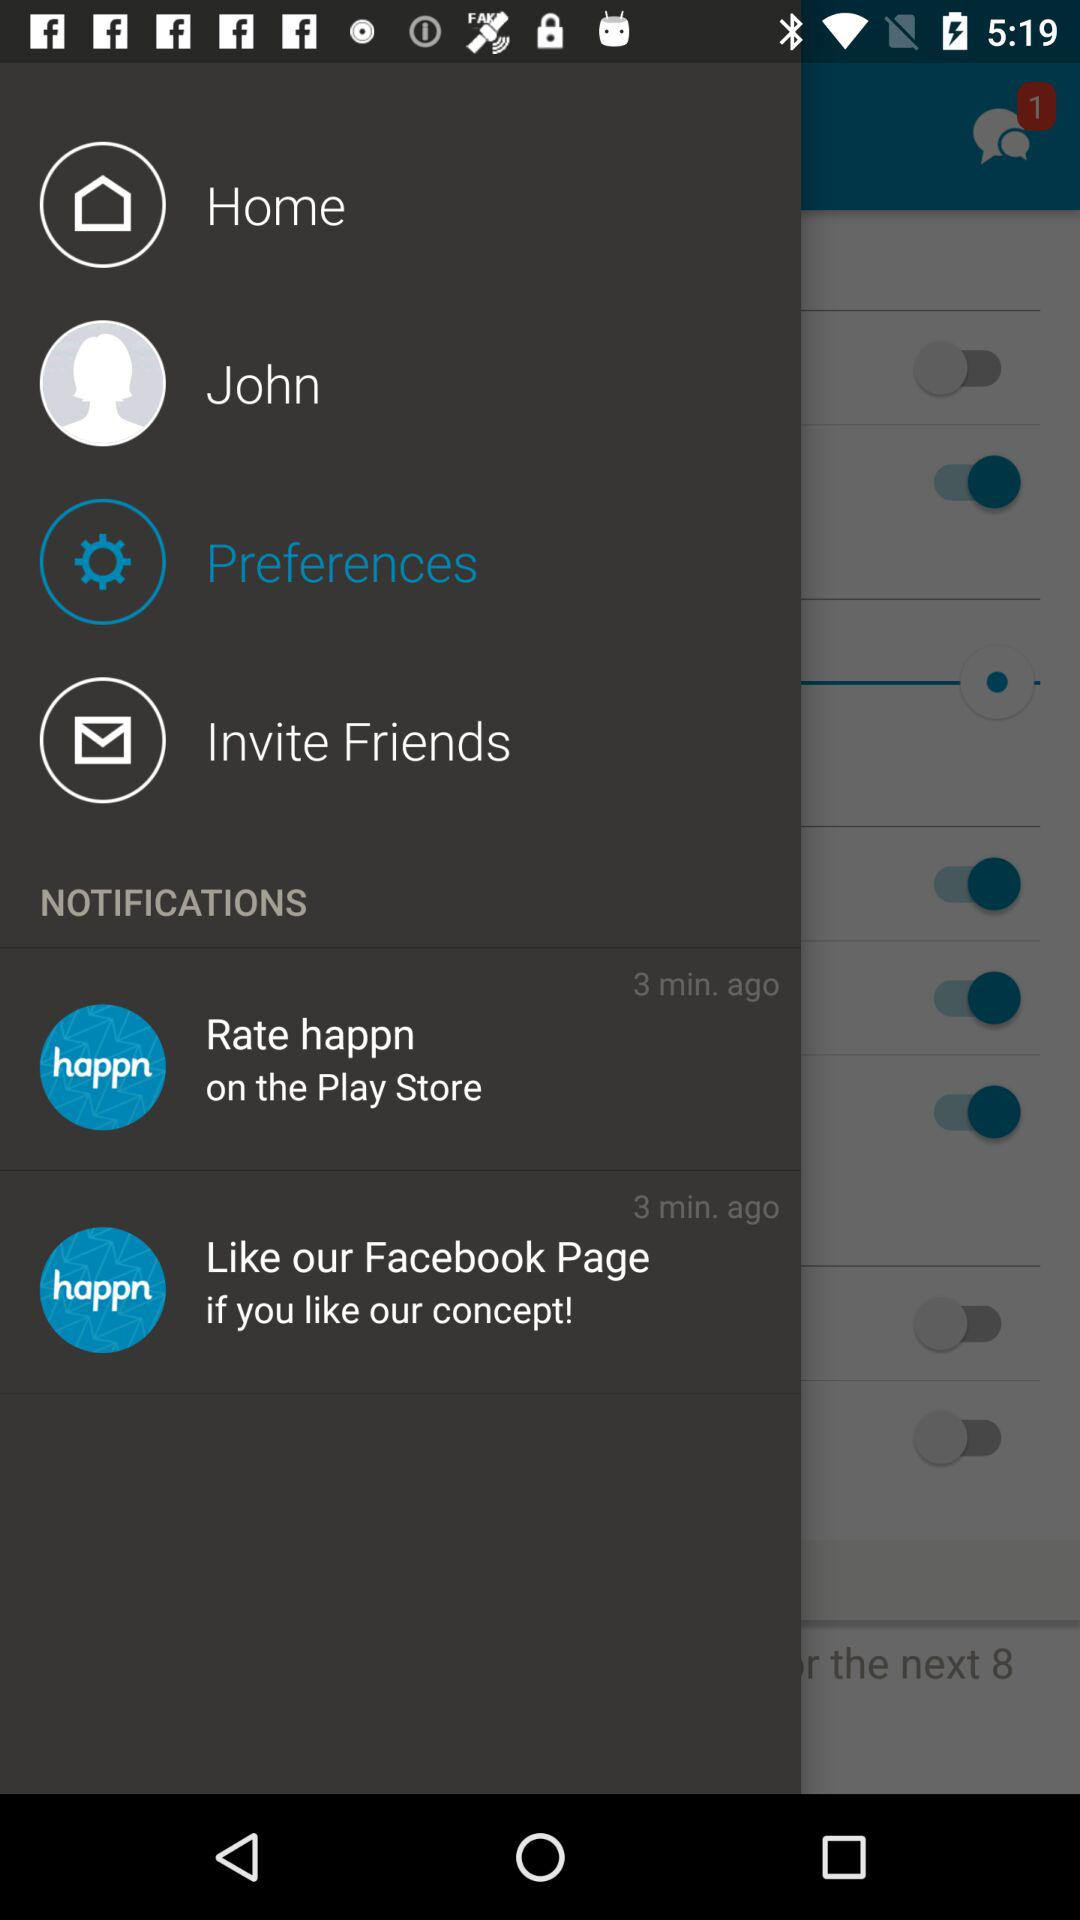What is the profile name? The profile name is John. 